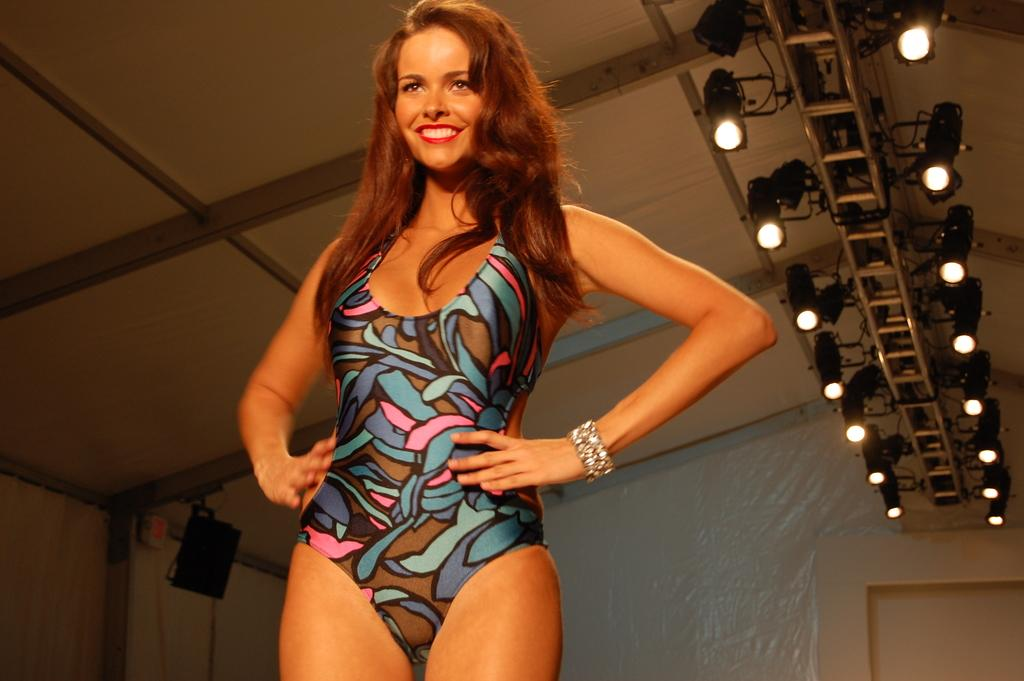Who is present in the image? There is a woman in the image. What is the woman's expression? The woman is smiling. What can be seen in the background of the image? There are lights and walls visible in the image. What is the purpose of the speaker in the image? The speaker is likely used for amplifying sound. Can you describe the objects in the image? There are some objects present, but their specific nature is not mentioned in the facts. What type of zipper can be seen on the cake in the image? There is no cake or zipper present in the image. What is the woman's tendency in the image? The facts provided do not mention any specific tendencies of the woman in the image. 